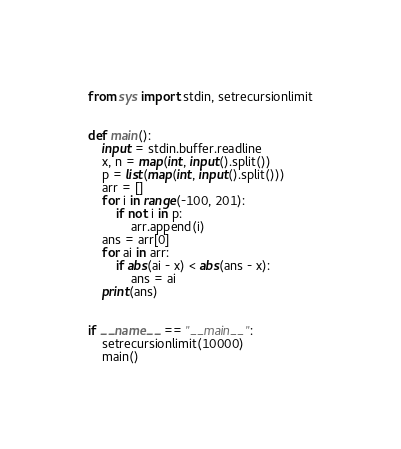Convert code to text. <code><loc_0><loc_0><loc_500><loc_500><_Python_>from sys import stdin, setrecursionlimit


def main():
    input = stdin.buffer.readline
    x, n = map(int, input().split())
    p = list(map(int, input().split()))
    arr = []
    for i in range(-100, 201):
        if not i in p:
            arr.append(i)
    ans = arr[0]
    for ai in arr:
        if abs(ai - x) < abs(ans - x):
            ans = ai
    print(ans)


if __name__ == "__main__":
    setrecursionlimit(10000)
    main()
</code> 